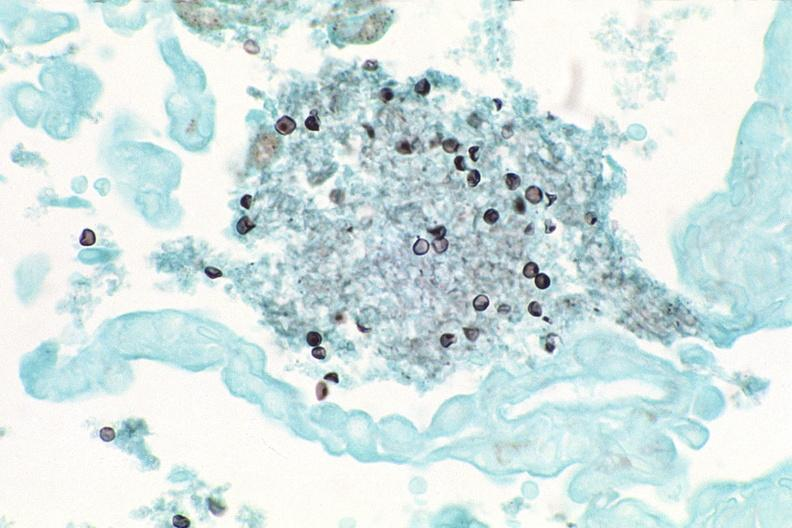where is this?
Answer the question using a single word or phrase. Lung 